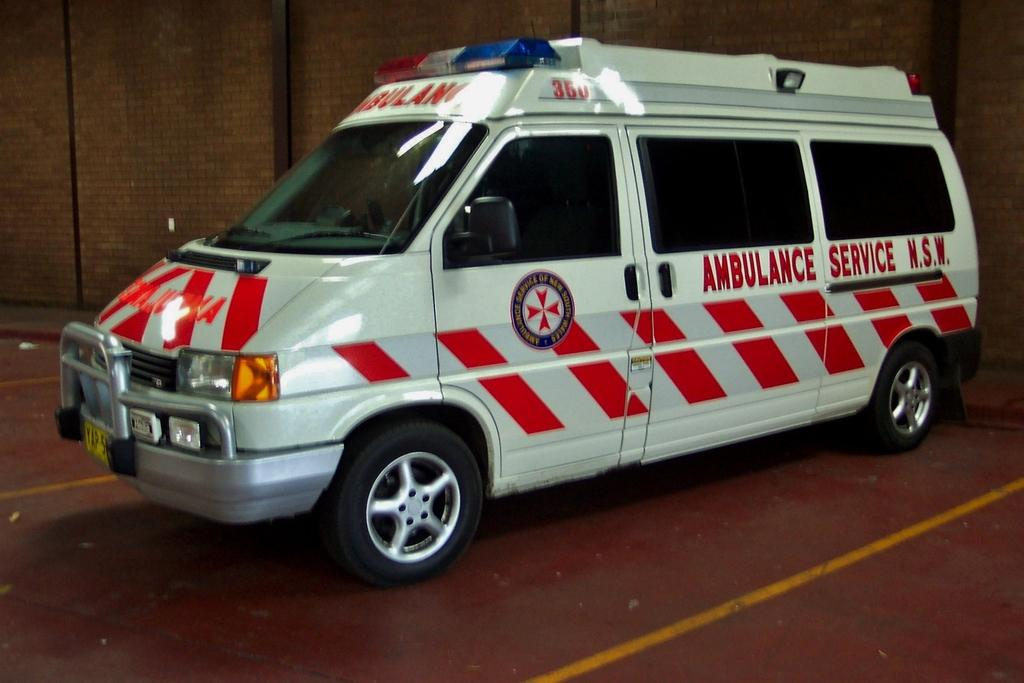<image>
Render a clear and concise summary of the photo. A grey and red ambulance that reads "Ambulance Service" on the side sits in a parking lot 